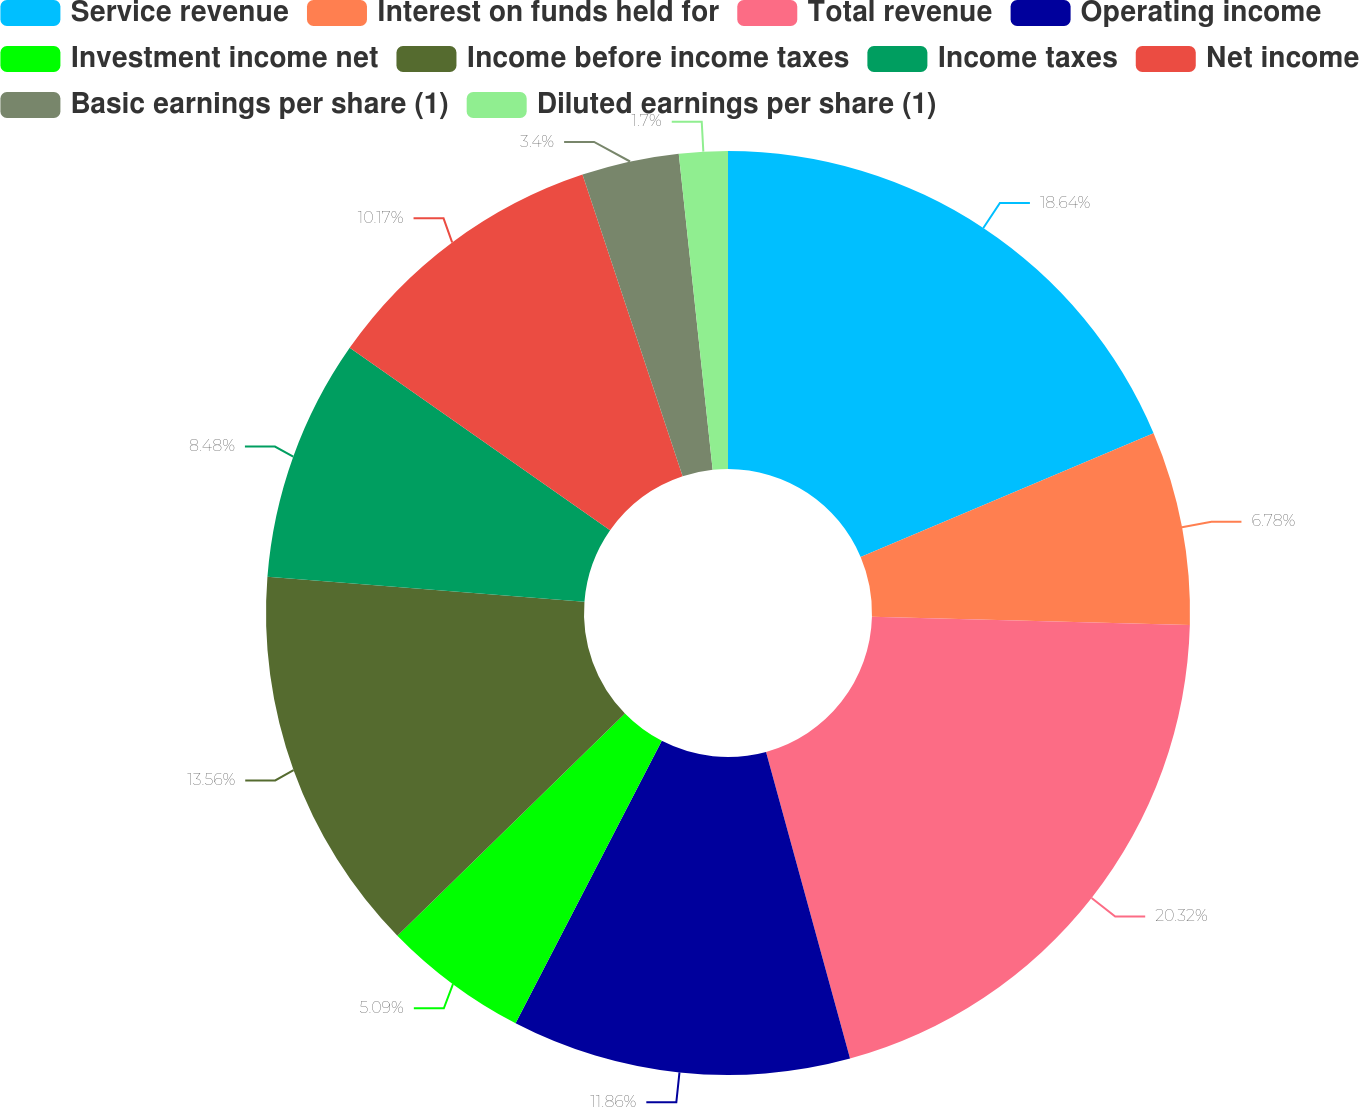Convert chart. <chart><loc_0><loc_0><loc_500><loc_500><pie_chart><fcel>Service revenue<fcel>Interest on funds held for<fcel>Total revenue<fcel>Operating income<fcel>Investment income net<fcel>Income before income taxes<fcel>Income taxes<fcel>Net income<fcel>Basic earnings per share (1)<fcel>Diluted earnings per share (1)<nl><fcel>18.64%<fcel>6.78%<fcel>20.33%<fcel>11.86%<fcel>5.09%<fcel>13.56%<fcel>8.48%<fcel>10.17%<fcel>3.4%<fcel>1.7%<nl></chart> 